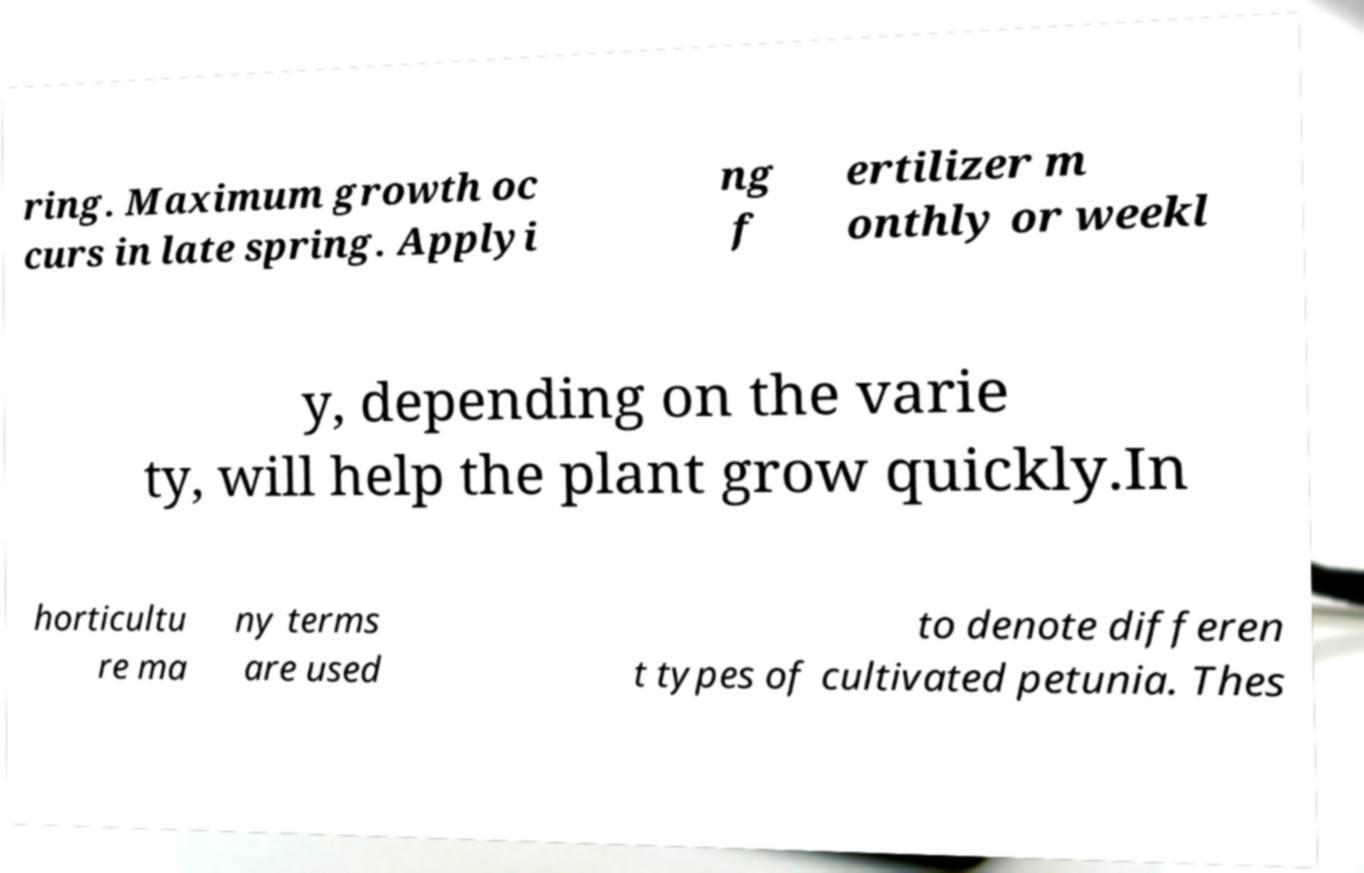What messages or text are displayed in this image? I need them in a readable, typed format. ring. Maximum growth oc curs in late spring. Applyi ng f ertilizer m onthly or weekl y, depending on the varie ty, will help the plant grow quickly.In horticultu re ma ny terms are used to denote differen t types of cultivated petunia. Thes 